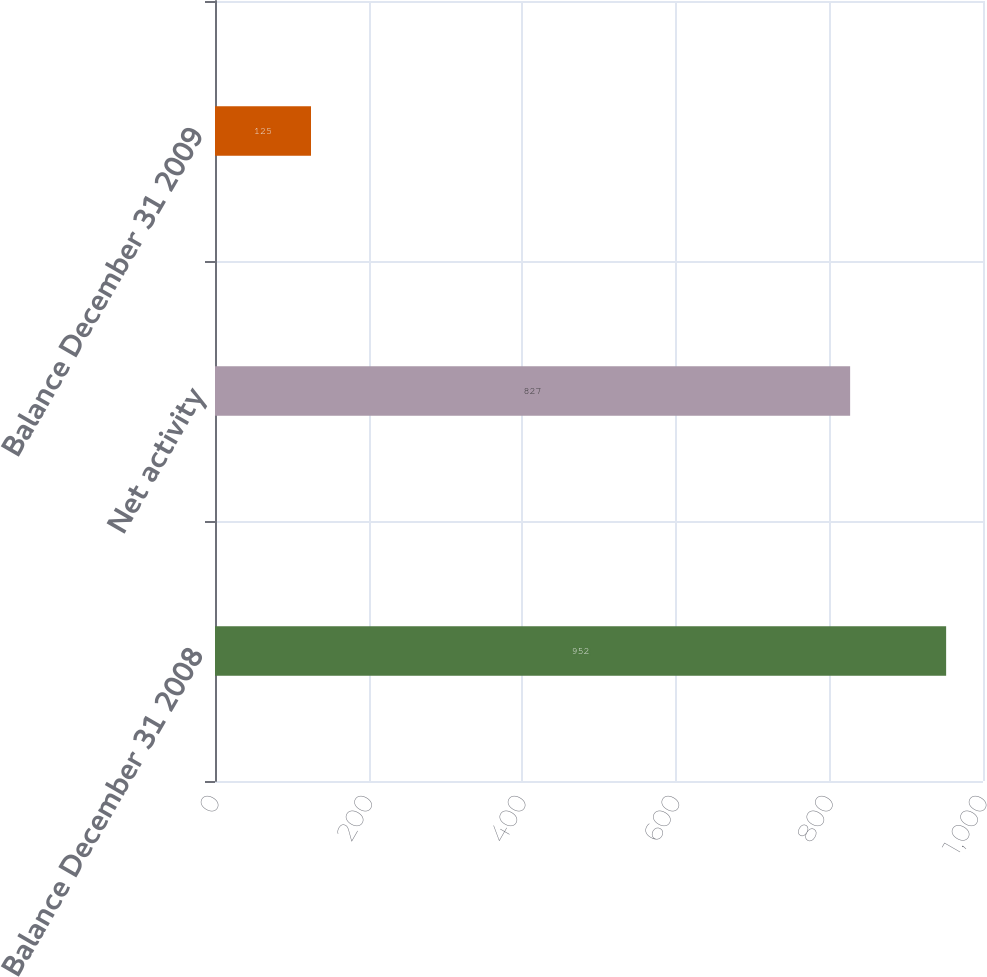Convert chart. <chart><loc_0><loc_0><loc_500><loc_500><bar_chart><fcel>Balance December 31 2008<fcel>Net activity<fcel>Balance December 31 2009<nl><fcel>952<fcel>827<fcel>125<nl></chart> 